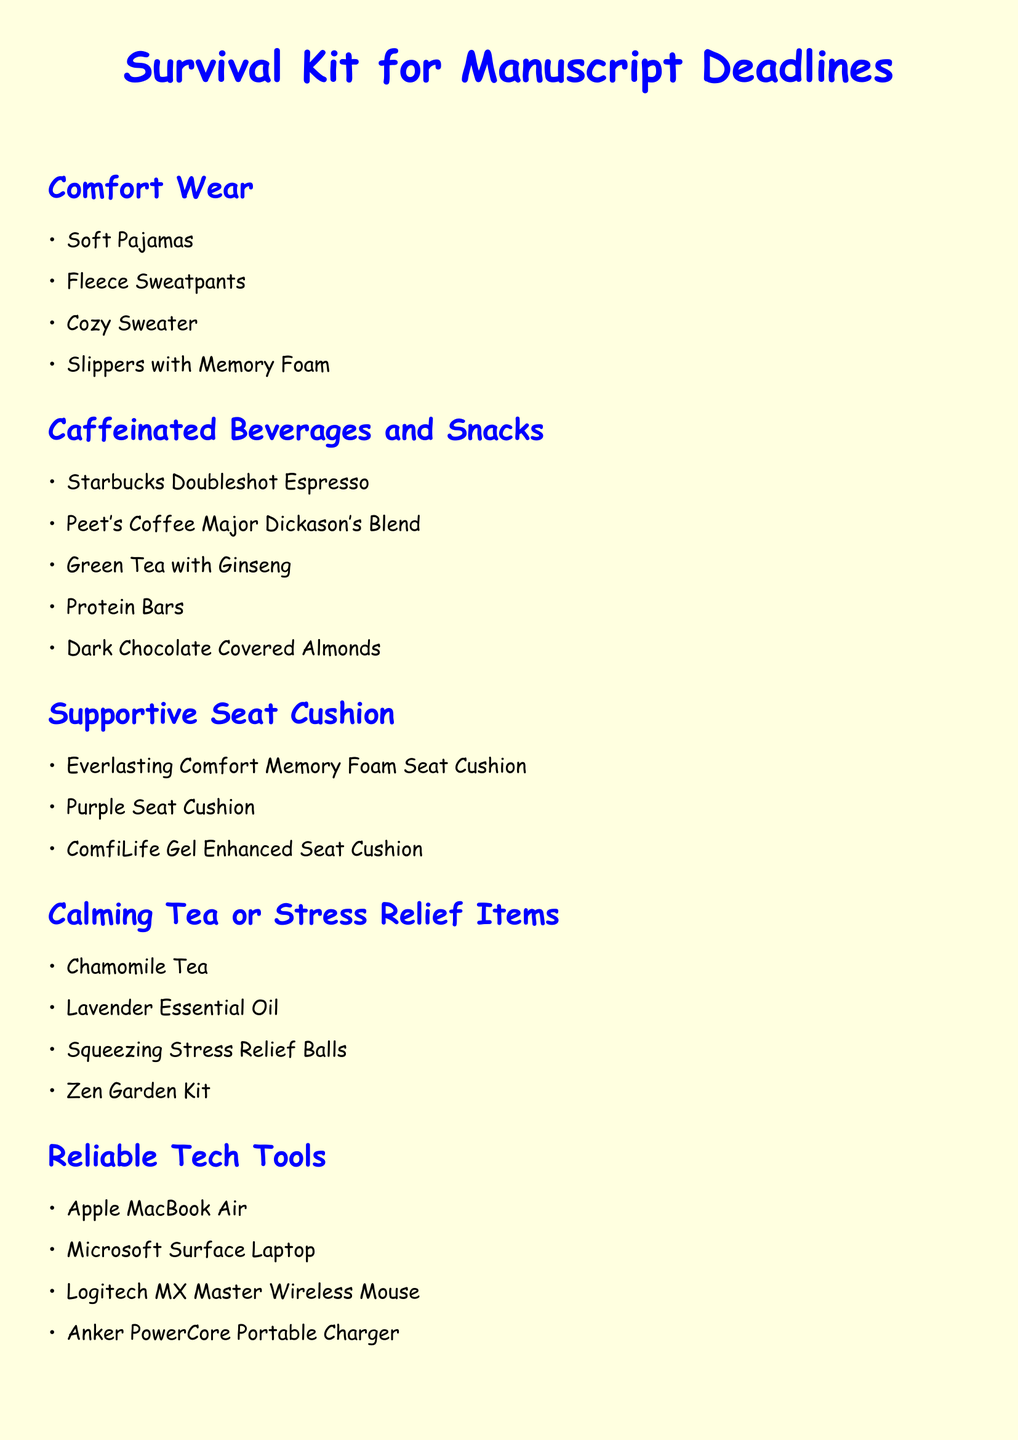What items are listed under Comfort Wear? Comfort Wear includes several clothing items listed in the document.
Answer: Soft Pajamas, Fleece Sweatpants, Cozy Sweater, Slippers with Memory Foam How many caffeinated beverages are mentioned? The document lists specific caffeinated beverages meant for comfort during manuscript deadlines.
Answer: Five What is a recommended calming tea? One of the calming tea options specified in the document.
Answer: Chamomile Tea What is suggested for a supportive seat cushion? The document provides specific product names for seat cushions designed for comfort.
Answer: Everlasting Comfort Memory Foam Seat Cushion What tech tools are included in the survival kit? The Reliable Tech Tools section lists devices that are helpful for writers during deadlines.
Answer: Apple MacBook Air, Microsoft Surface Laptop, Logitech MX Master Wireless Mouse, Anker PowerCore Portable Charger What should you do if tech troubles arise? The document provides guidance on how to seek help with tech issues.
Answer: Immediately contact your developer What scent is suggested for stress relief? The document mentions a specific essential oil that is beneficial for stress relief.
Answer: Lavender Essential Oil How is the document visually styled? The document uses a specific font and colors to enhance readability and aesthetics.
Answer: Comic Sans MS, light yellow background 